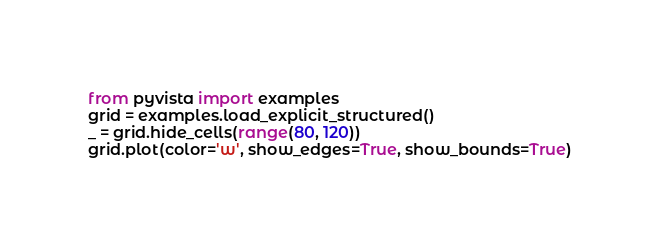Convert code to text. <code><loc_0><loc_0><loc_500><loc_500><_Python_>from pyvista import examples
grid = examples.load_explicit_structured()
_ = grid.hide_cells(range(80, 120))
grid.plot(color='w', show_edges=True, show_bounds=True)
</code> 